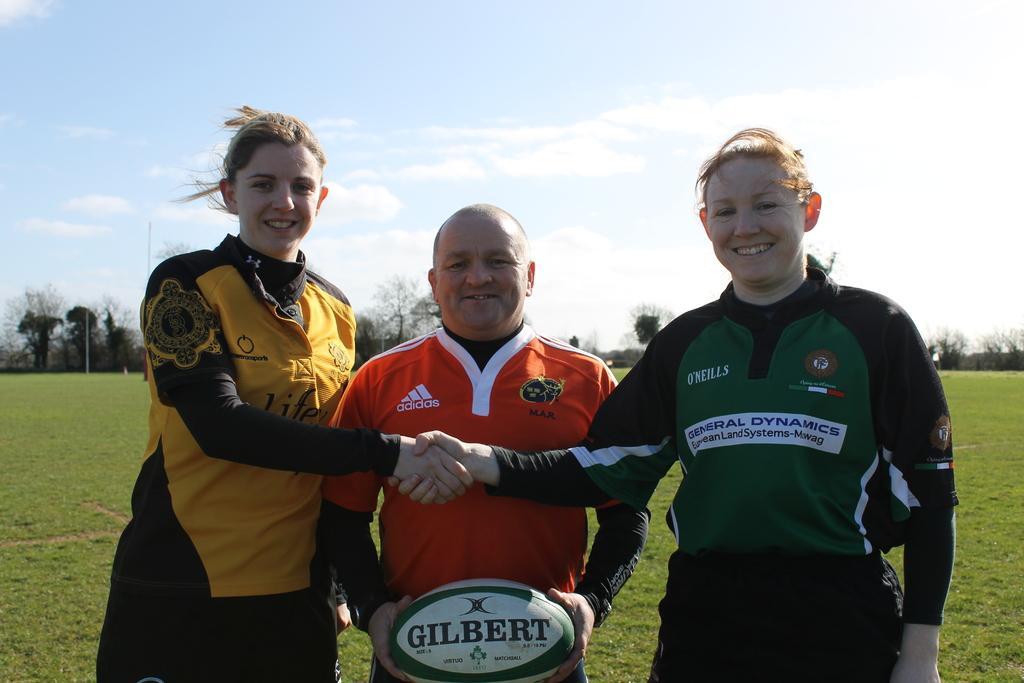How would you summarize this image in a sentence or two? In this image we can see three persons, two women and man holding ball in his hands, two women shaking their hands each other and at the background of the image there are some trees and clear sky. 